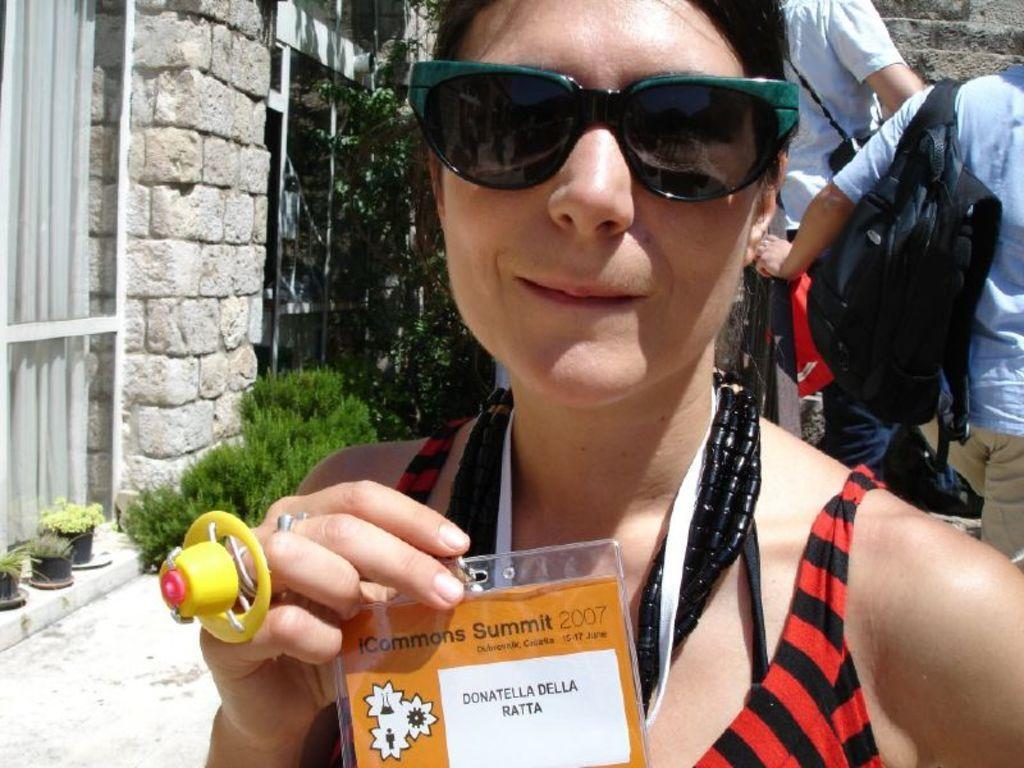How would you summarize this image in a sentence or two? There is a lady in the center of the image holding a card, she is wearing sunglasses, there are windows, greenery, people and a wall in the background area. 